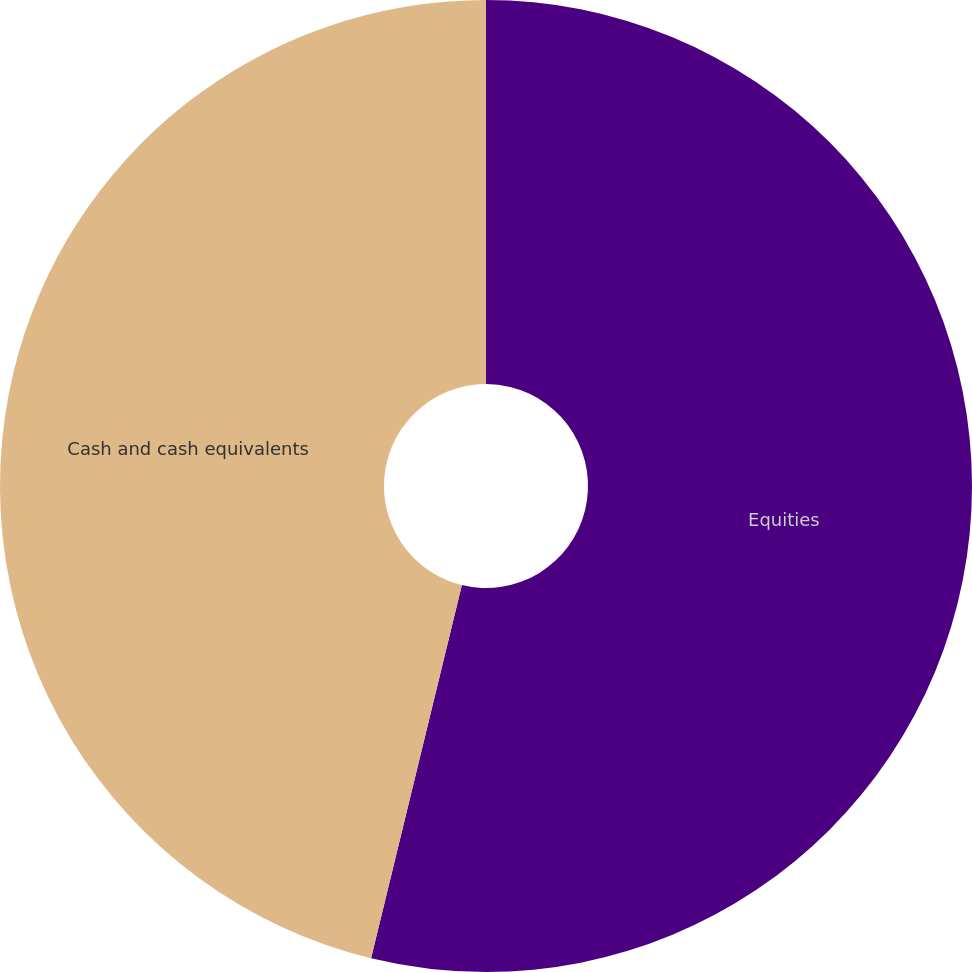Convert chart to OTSL. <chart><loc_0><loc_0><loc_500><loc_500><pie_chart><fcel>Equities<fcel>Cash and cash equivalents<nl><fcel>53.8%<fcel>46.2%<nl></chart> 